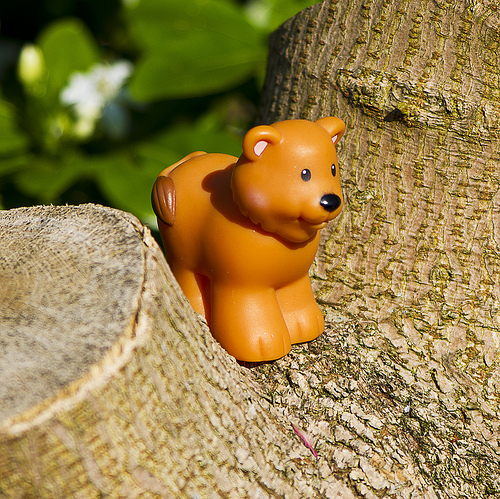<image>
Is there a toy in front of the tree? No. The toy is not in front of the tree. The spatial positioning shows a different relationship between these objects. 